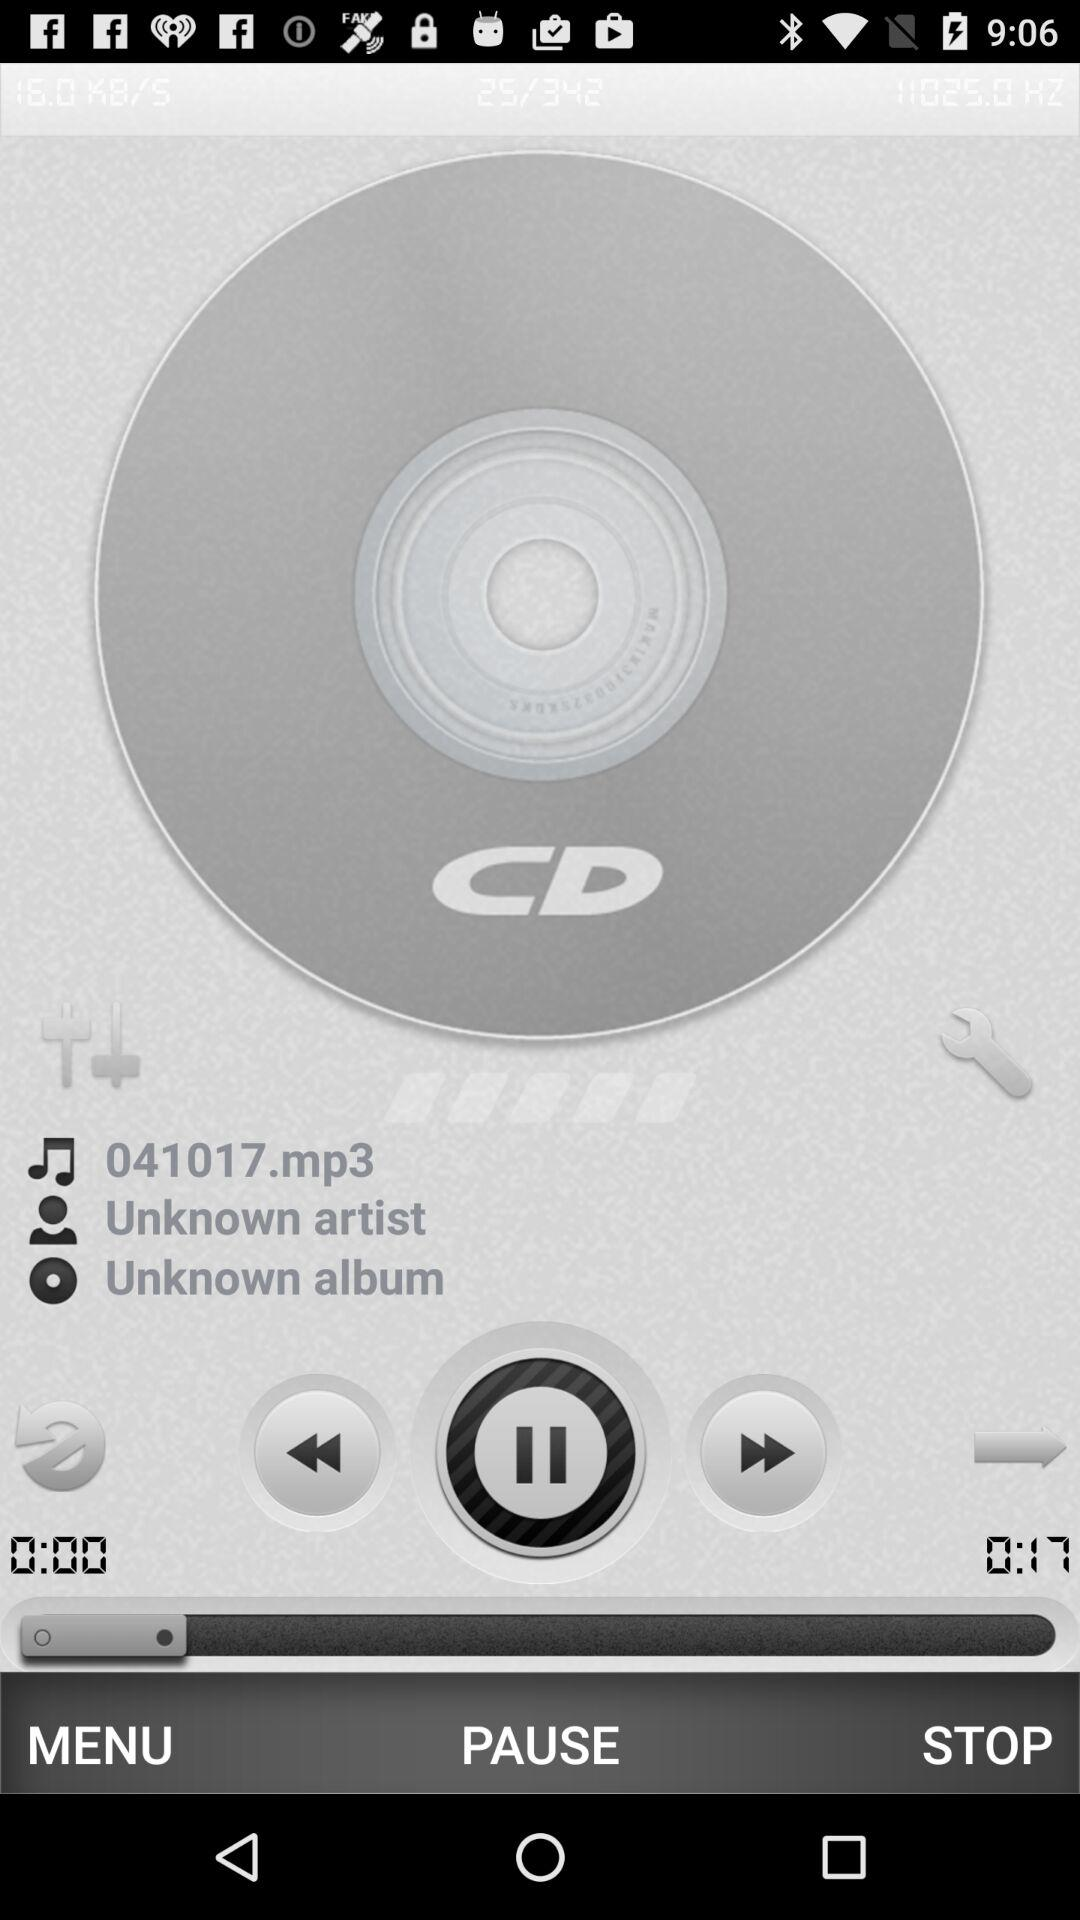Who is the artist of the audio? The artist is unknown. 